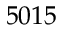<formula> <loc_0><loc_0><loc_500><loc_500>5 0 1 5</formula> 